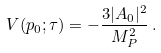Convert formula to latex. <formula><loc_0><loc_0><loc_500><loc_500>V ( p _ { 0 } ; \tau ) = - \frac { 3 | A _ { 0 } | ^ { 2 } } { M _ { P } ^ { 2 } } \, .</formula> 